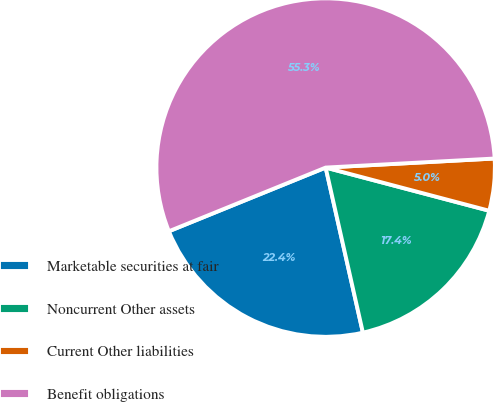<chart> <loc_0><loc_0><loc_500><loc_500><pie_chart><fcel>Marketable securities at fair<fcel>Noncurrent Other assets<fcel>Current Other liabilities<fcel>Benefit obligations<nl><fcel>22.39%<fcel>17.36%<fcel>4.96%<fcel>55.29%<nl></chart> 